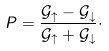<formula> <loc_0><loc_0><loc_500><loc_500>P = \frac { { \mathcal { G } _ { \uparrow } - \mathcal { G } _ { \downarrow } } } { { \mathcal { G } _ { \uparrow } + \mathcal { G } _ { \downarrow } } } \cdot</formula> 